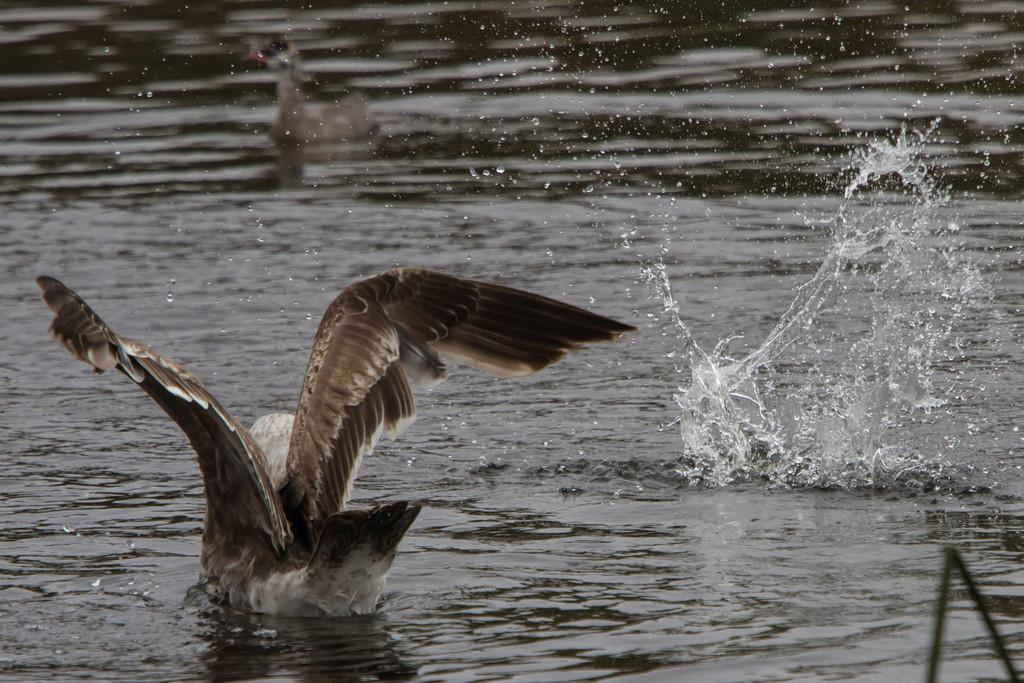What type of animal is in the image? There is a bird in the image. Where is the bird located? The bird is in the water. What colors can be seen on the bird? The bird has brown and white colors. What type of line can be seen in the image? There is no line present in the image. What note is the bird singing in the image? Birds do not sing specific notes, and there is no indication in the image that the bird is singing. 